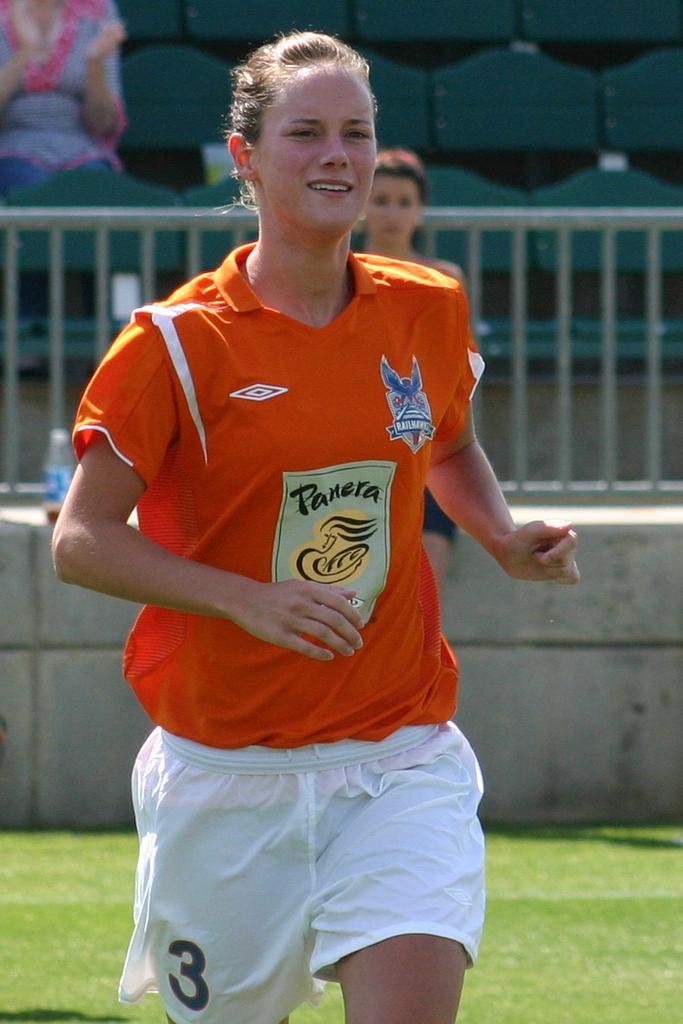<image>
Present a compact description of the photo's key features. female player #3 has a panera logo on her orange jersey 